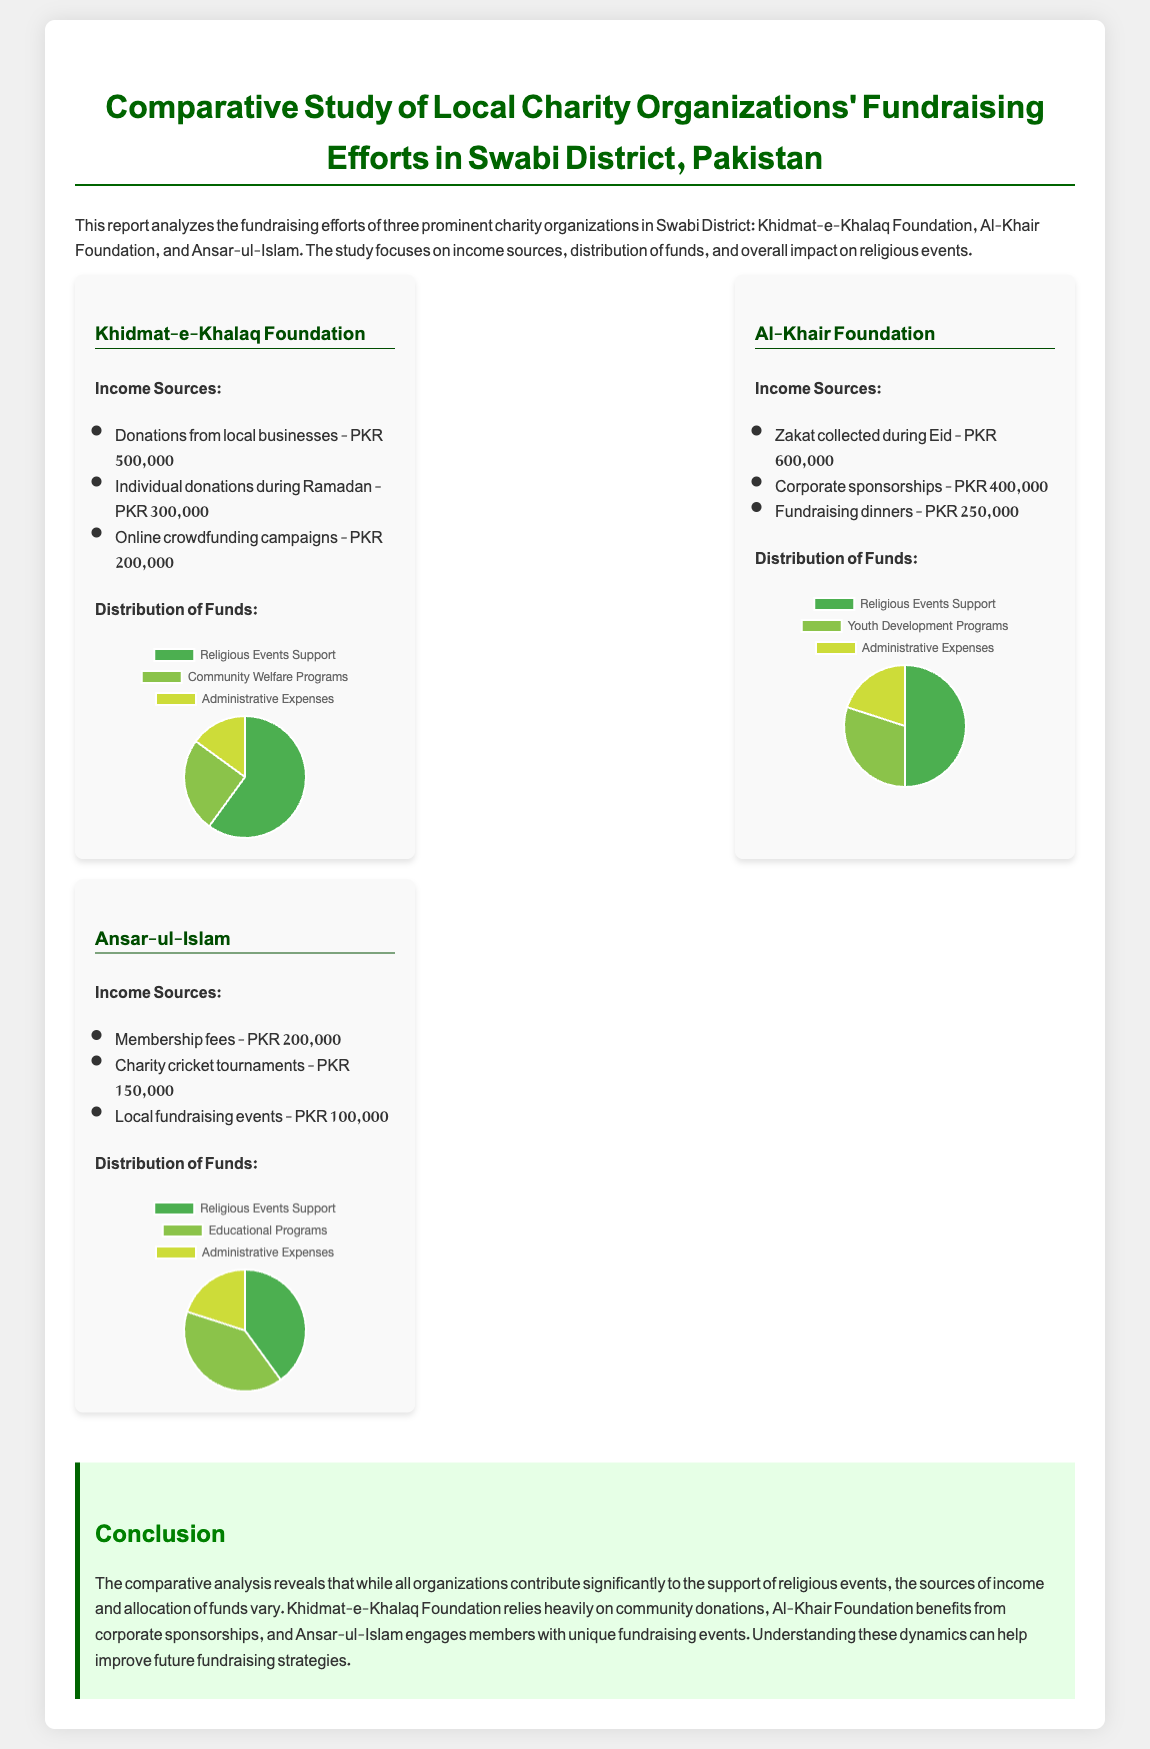What is the income from local businesses for Khidmat-e-Khalaq Foundation? The document states that Khidmat-e-Khalaq Foundation received PKR 500,000 from local businesses.
Answer: PKR 500,000 What is the total income for Al-Khair Foundation? The total income for Al-Khair Foundation is derived from Zakat collected (PKR 600,000), corporate sponsorships (PKR 400,000), and fundraising dinners (PKR 250,000), which adds up to PKR 1,250,000.
Answer: PKR 1,250,000 Which organization has the highest income from donations during Ramadan? According to the document, Khidmat-e-Khalaq Foundation has the highest income from donations during Ramadan, receiving PKR 300,000.
Answer: Khidmat-e-Khalaq Foundation What percentage of funds does Ansar-ul-Islam allocate to Religious Events Support? The document indicates that Ansar-ul-Islam allocates 40% of its funds to Religious Events Support.
Answer: 40% Which organization depends significantly on corporate sponsorships? The analysis shows that Al-Khair Foundation benefits significantly from corporate sponsorships, receiving PKR 400,000.
Answer: Al-Khair Foundation What are the total funds allocated for administrative expenses by Khidmat-e-Khalaq Foundation? The document states that Khidmat-e-Khalaq Foundation allocates 15% of its funds to administrative expenses.
Answer: 15% What type of fundraising events does Ansar-ul-Islam use to generate income? The document mentions that Ansar-ul-Islam uses local fundraising events and charity cricket tournaments to generate income.
Answer: Local fundraising events and charity cricket tournaments What is the comparison of income sources among the three organizations? The document compares income sources and indicates that Khidmat-e-Khalaq Foundation relies on community donations, Al-Khair Foundation on corporate sponsorships, and Ansar-ul-Islam on member fees and events.
Answer: Community donations, corporate sponsorships, member fees and events 